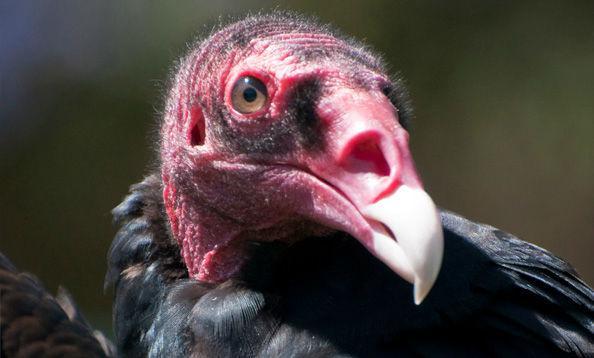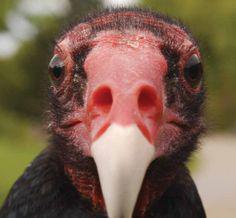The first image is the image on the left, the second image is the image on the right. Analyze the images presented: Is the assertion "The bird in the left image is looking towards the left." valid? Answer yes or no. No. The first image is the image on the left, the second image is the image on the right. For the images displayed, is the sentence "Left and right images show heads of vultures facing opposite left-or-right directions." factually correct? Answer yes or no. No. 